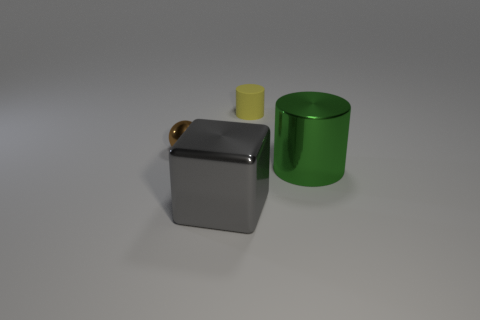Do the small matte object and the tiny thing that is on the left side of the gray thing have the same shape?
Your answer should be very brief. No. Is the number of green cylinders greater than the number of blue cylinders?
Your answer should be compact. Yes. Is the shape of the small thing behind the tiny brown object the same as  the big green object?
Ensure brevity in your answer.  Yes. Is the number of gray objects in front of the small brown sphere greater than the number of tiny blue balls?
Provide a short and direct response. Yes. There is a big metallic thing left of the small thing that is right of the brown metallic ball; what is its color?
Give a very brief answer. Gray. What number of gray things are there?
Your answer should be compact. 1. What number of things are on the right side of the brown object and in front of the tiny cylinder?
Provide a succinct answer. 2. Is there anything else that has the same shape as the small brown thing?
Keep it short and to the point. No. There is a large gray thing that is in front of the yellow cylinder; what shape is it?
Provide a short and direct response. Cube. How many other things are the same material as the large gray thing?
Provide a succinct answer. 2. 